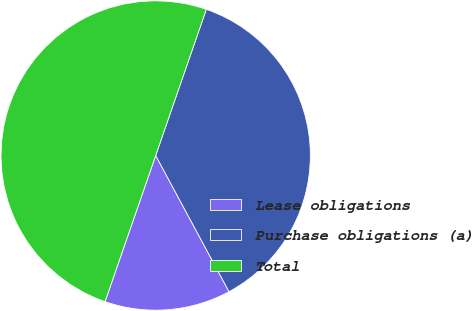<chart> <loc_0><loc_0><loc_500><loc_500><pie_chart><fcel>Lease obligations<fcel>Purchase obligations (a)<fcel>Total<nl><fcel>13.17%<fcel>36.83%<fcel>50.0%<nl></chart> 